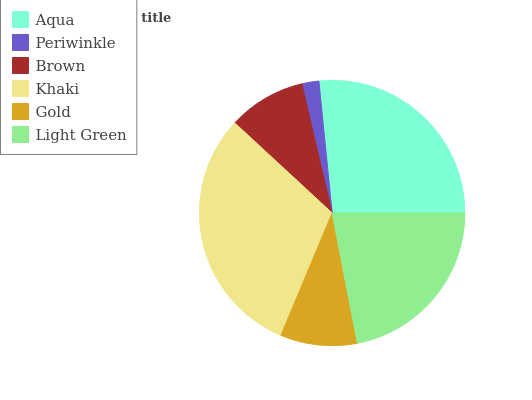Is Periwinkle the minimum?
Answer yes or no. Yes. Is Khaki the maximum?
Answer yes or no. Yes. Is Brown the minimum?
Answer yes or no. No. Is Brown the maximum?
Answer yes or no. No. Is Brown greater than Periwinkle?
Answer yes or no. Yes. Is Periwinkle less than Brown?
Answer yes or no. Yes. Is Periwinkle greater than Brown?
Answer yes or no. No. Is Brown less than Periwinkle?
Answer yes or no. No. Is Light Green the high median?
Answer yes or no. Yes. Is Brown the low median?
Answer yes or no. Yes. Is Gold the high median?
Answer yes or no. No. Is Gold the low median?
Answer yes or no. No. 